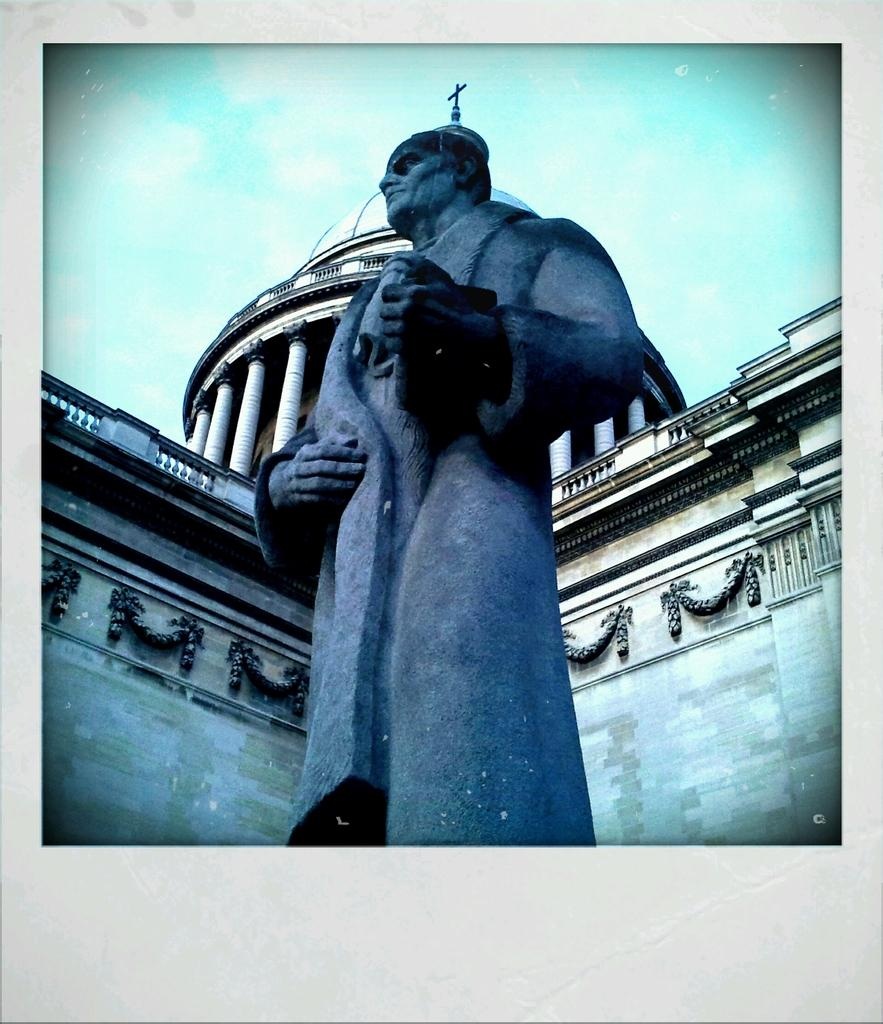What is the main subject in the image? There is a statue of a person in the image. In which direction is the statue facing? The statue is facing towards the left side. What can be seen in the background of the image? There is a building in the background of the image. What is visible at the top of the image? The sky is visible at the top of the image. What is the tendency of the harbor in the image? There is no harbor present in the image, so it is not possible to determine any tendencies related to a harbor. 